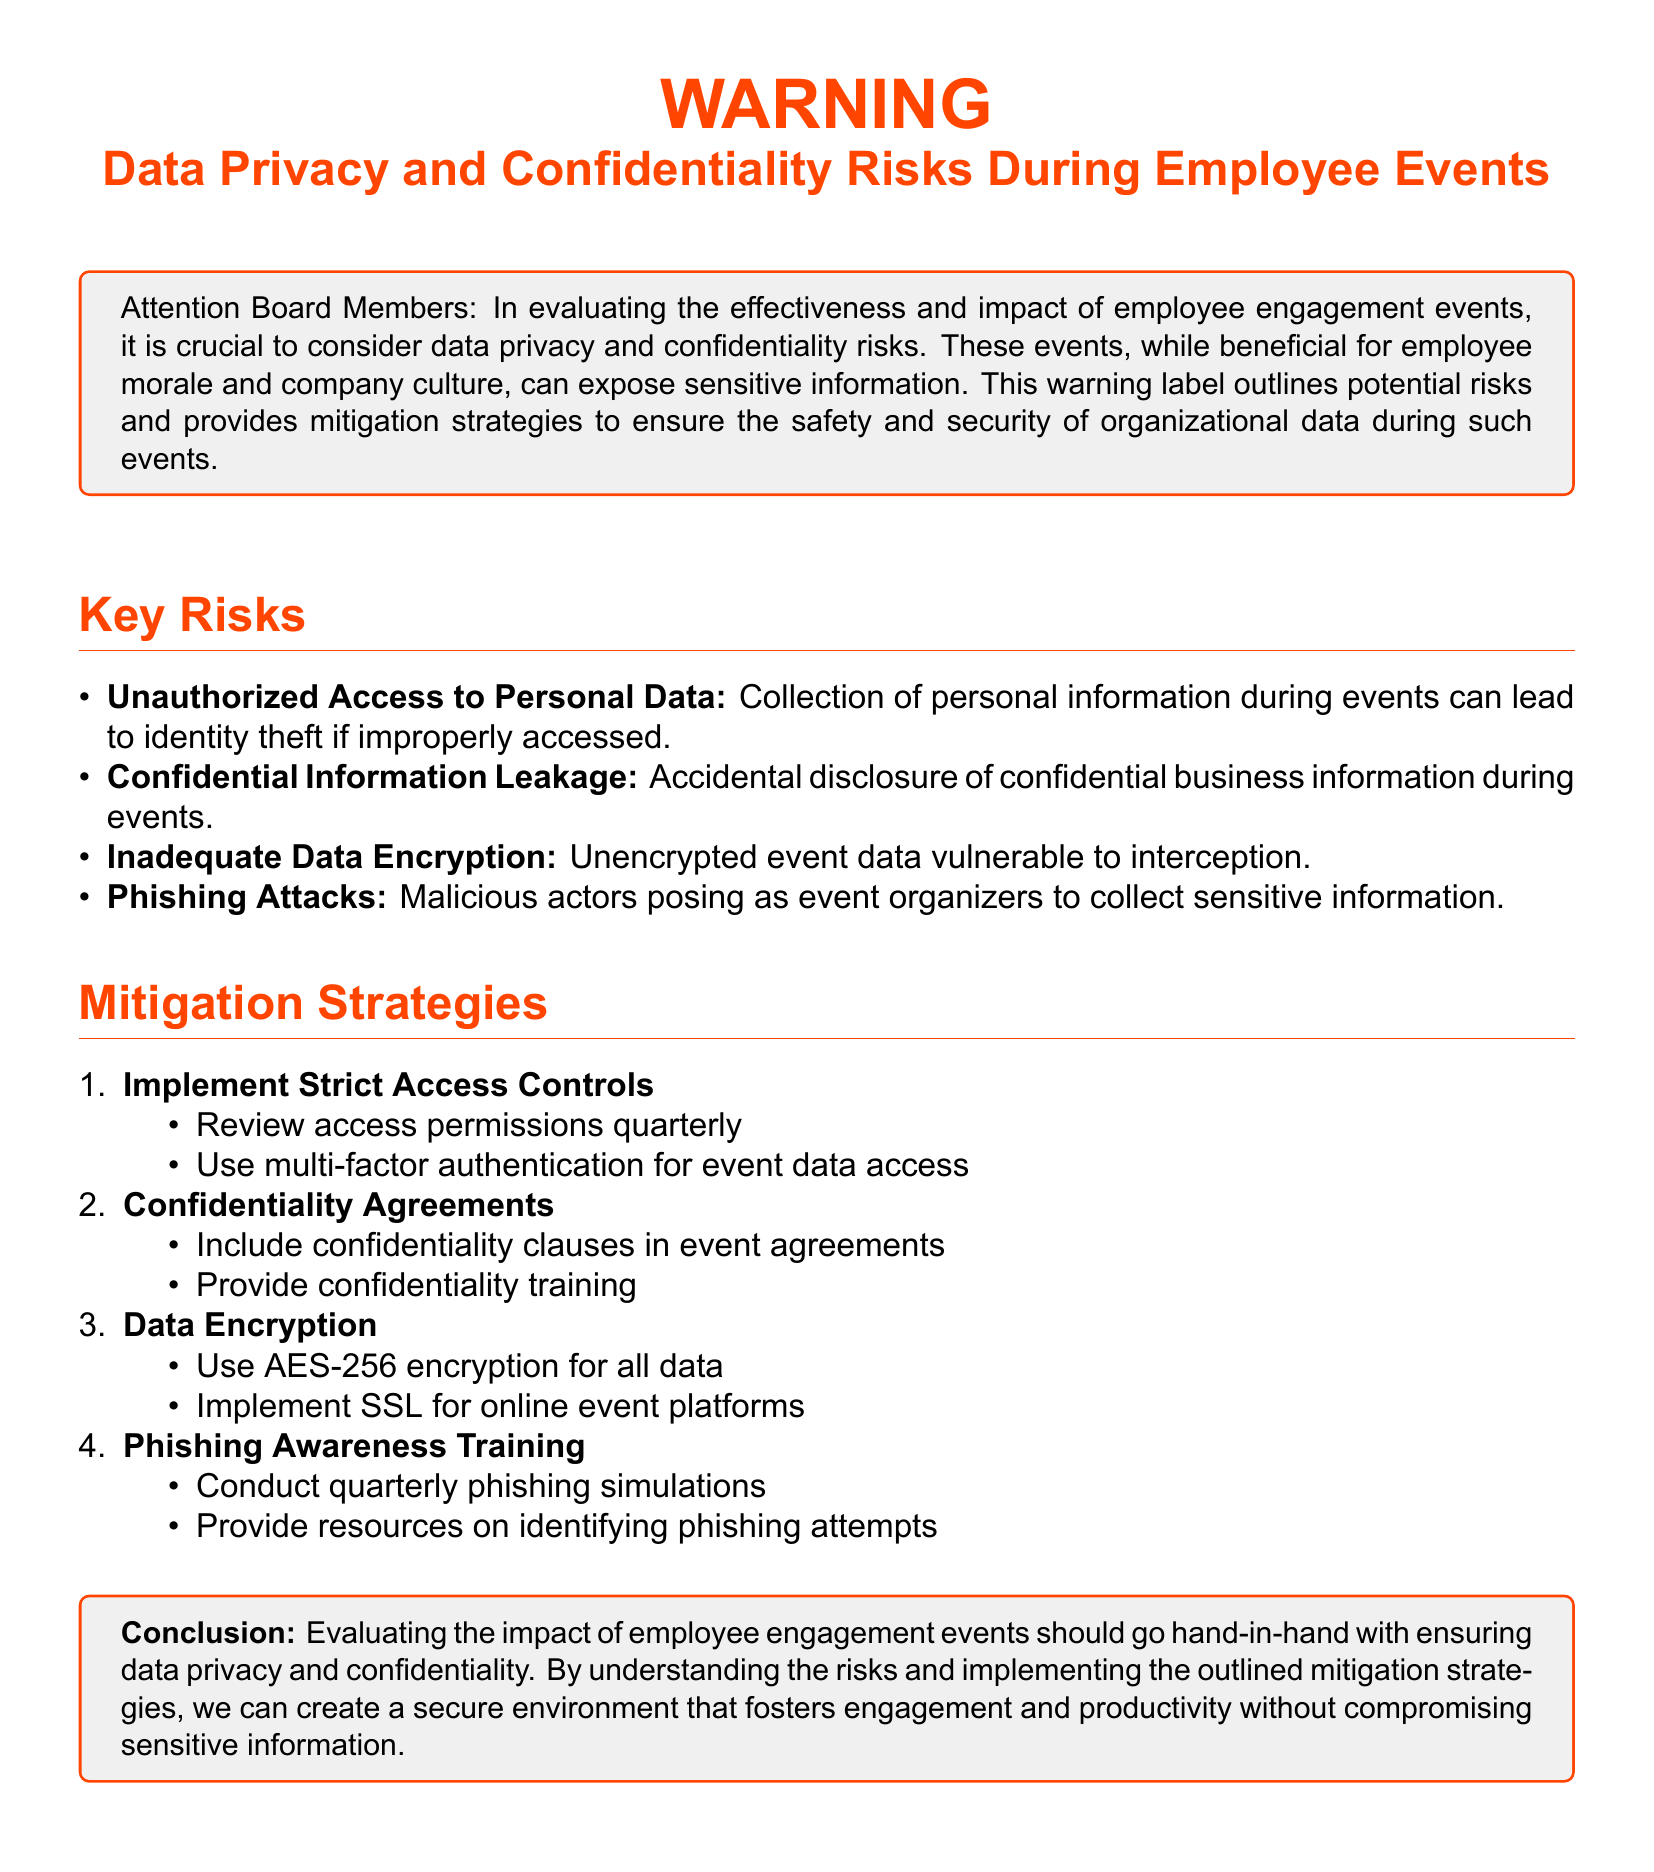What is the key color used for the warning? The document prominently features the color warning red for emphasis on warning content.
Answer: warning red What is one risk associated with employee events? The document lists several risks, one of which is unauthorized access to personal data.
Answer: Unauthorized Access to Personal Data How many mitigation strategies are outlined in the document? The document enumerates four distinct strategies to mitigate risks.
Answer: 4 What encryption standard is recommended for data? The document specifies the use of AES-256 encryption for all event data.
Answer: AES-256 What type of training is suggested to combat phishing attacks? The document mentions implementing phishing awareness training to help employees recognize threats.
Answer: Phishing Awareness Training When should access permissions be reviewed? Access permissions should be reviewed quarterly, as stated in the mitigation strategies.
Answer: Quarterly What kind of agreements should be included in event contracts? The document calls for the inclusion of confidentiality clauses in event agreements.
Answer: Confidentiality Agreements What is the purpose of implementing SSL? The document recommends SSL for online event platforms to enhance data security.
Answer: Data Security 